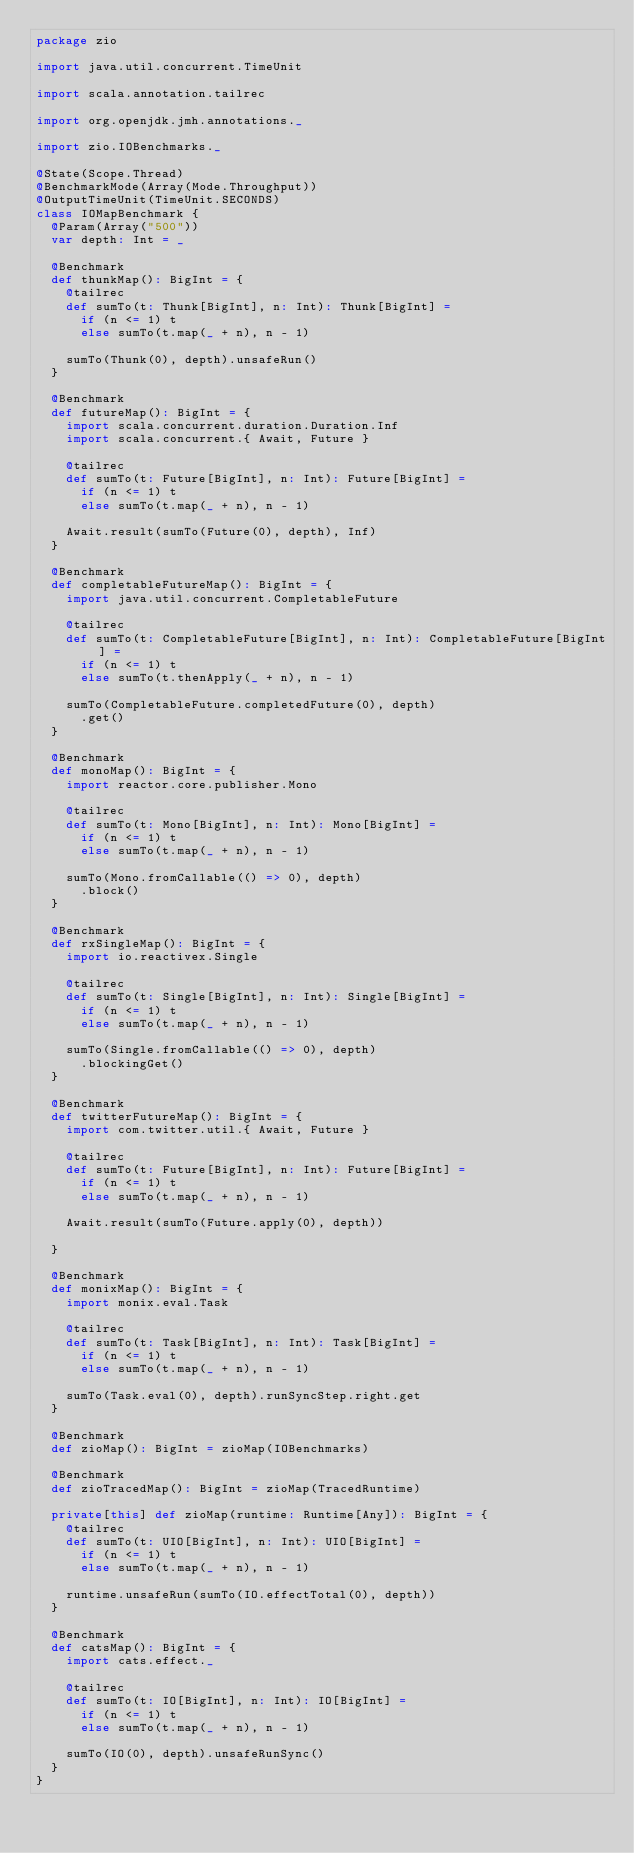<code> <loc_0><loc_0><loc_500><loc_500><_Scala_>package zio

import java.util.concurrent.TimeUnit

import scala.annotation.tailrec

import org.openjdk.jmh.annotations._

import zio.IOBenchmarks._

@State(Scope.Thread)
@BenchmarkMode(Array(Mode.Throughput))
@OutputTimeUnit(TimeUnit.SECONDS)
class IOMapBenchmark {
  @Param(Array("500"))
  var depth: Int = _

  @Benchmark
  def thunkMap(): BigInt = {
    @tailrec
    def sumTo(t: Thunk[BigInt], n: Int): Thunk[BigInt] =
      if (n <= 1) t
      else sumTo(t.map(_ + n), n - 1)

    sumTo(Thunk(0), depth).unsafeRun()
  }

  @Benchmark
  def futureMap(): BigInt = {
    import scala.concurrent.duration.Duration.Inf
    import scala.concurrent.{ Await, Future }

    @tailrec
    def sumTo(t: Future[BigInt], n: Int): Future[BigInt] =
      if (n <= 1) t
      else sumTo(t.map(_ + n), n - 1)

    Await.result(sumTo(Future(0), depth), Inf)
  }

  @Benchmark
  def completableFutureMap(): BigInt = {
    import java.util.concurrent.CompletableFuture

    @tailrec
    def sumTo(t: CompletableFuture[BigInt], n: Int): CompletableFuture[BigInt] =
      if (n <= 1) t
      else sumTo(t.thenApply(_ + n), n - 1)

    sumTo(CompletableFuture.completedFuture(0), depth)
      .get()
  }

  @Benchmark
  def monoMap(): BigInt = {
    import reactor.core.publisher.Mono

    @tailrec
    def sumTo(t: Mono[BigInt], n: Int): Mono[BigInt] =
      if (n <= 1) t
      else sumTo(t.map(_ + n), n - 1)

    sumTo(Mono.fromCallable(() => 0), depth)
      .block()
  }

  @Benchmark
  def rxSingleMap(): BigInt = {
    import io.reactivex.Single

    @tailrec
    def sumTo(t: Single[BigInt], n: Int): Single[BigInt] =
      if (n <= 1) t
      else sumTo(t.map(_ + n), n - 1)

    sumTo(Single.fromCallable(() => 0), depth)
      .blockingGet()
  }

  @Benchmark
  def twitterFutureMap(): BigInt = {
    import com.twitter.util.{ Await, Future }

    @tailrec
    def sumTo(t: Future[BigInt], n: Int): Future[BigInt] =
      if (n <= 1) t
      else sumTo(t.map(_ + n), n - 1)

    Await.result(sumTo(Future.apply(0), depth))

  }

  @Benchmark
  def monixMap(): BigInt = {
    import monix.eval.Task

    @tailrec
    def sumTo(t: Task[BigInt], n: Int): Task[BigInt] =
      if (n <= 1) t
      else sumTo(t.map(_ + n), n - 1)

    sumTo(Task.eval(0), depth).runSyncStep.right.get
  }

  @Benchmark
  def zioMap(): BigInt = zioMap(IOBenchmarks)

  @Benchmark
  def zioTracedMap(): BigInt = zioMap(TracedRuntime)

  private[this] def zioMap(runtime: Runtime[Any]): BigInt = {
    @tailrec
    def sumTo(t: UIO[BigInt], n: Int): UIO[BigInt] =
      if (n <= 1) t
      else sumTo(t.map(_ + n), n - 1)

    runtime.unsafeRun(sumTo(IO.effectTotal(0), depth))
  }

  @Benchmark
  def catsMap(): BigInt = {
    import cats.effect._

    @tailrec
    def sumTo(t: IO[BigInt], n: Int): IO[BigInt] =
      if (n <= 1) t
      else sumTo(t.map(_ + n), n - 1)

    sumTo(IO(0), depth).unsafeRunSync()
  }
}
</code> 